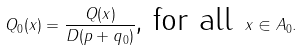Convert formula to latex. <formula><loc_0><loc_0><loc_500><loc_500>Q _ { 0 } ( x ) = \frac { Q ( x ) } { D ( p + q _ { 0 } ) } \text {, for all } x \in A _ { 0 } .</formula> 